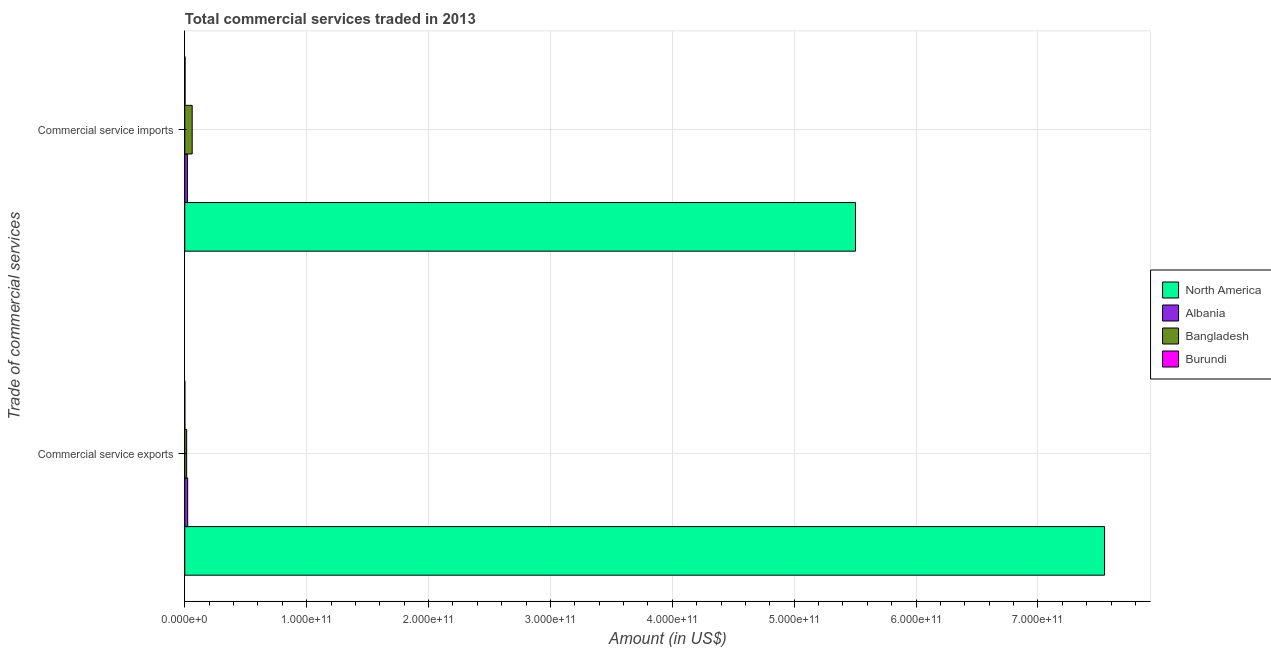How many bars are there on the 1st tick from the top?
Your answer should be very brief. 4. What is the label of the 1st group of bars from the top?
Make the answer very short. Commercial service imports. What is the amount of commercial service imports in Bangladesh?
Provide a succinct answer. 6.08e+09. Across all countries, what is the maximum amount of commercial service imports?
Provide a succinct answer. 5.50e+11. Across all countries, what is the minimum amount of commercial service imports?
Keep it short and to the point. 2.21e+08. In which country was the amount of commercial service exports maximum?
Your answer should be very brief. North America. In which country was the amount of commercial service exports minimum?
Provide a short and direct response. Burundi. What is the total amount of commercial service exports in the graph?
Your answer should be compact. 7.59e+11. What is the difference between the amount of commercial service exports in Bangladesh and that in Burundi?
Your answer should be compact. 1.50e+09. What is the difference between the amount of commercial service exports in Burundi and the amount of commercial service imports in Albania?
Your answer should be very brief. -2.13e+09. What is the average amount of commercial service exports per country?
Ensure brevity in your answer.  1.90e+11. What is the difference between the amount of commercial service imports and amount of commercial service exports in Burundi?
Give a very brief answer. 1.89e+08. In how many countries, is the amount of commercial service imports greater than 660000000000 US$?
Your response must be concise. 0. What is the ratio of the amount of commercial service imports in Bangladesh to that in North America?
Keep it short and to the point. 0.01. Is the amount of commercial service imports in Albania less than that in North America?
Your answer should be very brief. Yes. In how many countries, is the amount of commercial service imports greater than the average amount of commercial service imports taken over all countries?
Offer a very short reply. 1. What does the 2nd bar from the top in Commercial service exports represents?
Offer a very short reply. Bangladesh. What does the 1st bar from the bottom in Commercial service imports represents?
Provide a succinct answer. North America. How many bars are there?
Give a very brief answer. 8. What is the difference between two consecutive major ticks on the X-axis?
Your response must be concise. 1.00e+11. How are the legend labels stacked?
Offer a very short reply. Vertical. What is the title of the graph?
Your response must be concise. Total commercial services traded in 2013. What is the label or title of the Y-axis?
Offer a very short reply. Trade of commercial services. What is the Amount (in US$) of North America in Commercial service exports?
Keep it short and to the point. 7.55e+11. What is the Amount (in US$) of Albania in Commercial service exports?
Your answer should be compact. 2.39e+09. What is the Amount (in US$) of Bangladesh in Commercial service exports?
Your response must be concise. 1.53e+09. What is the Amount (in US$) in Burundi in Commercial service exports?
Keep it short and to the point. 3.23e+07. What is the Amount (in US$) in North America in Commercial service imports?
Keep it short and to the point. 5.50e+11. What is the Amount (in US$) of Albania in Commercial service imports?
Make the answer very short. 2.17e+09. What is the Amount (in US$) in Bangladesh in Commercial service imports?
Ensure brevity in your answer.  6.08e+09. What is the Amount (in US$) of Burundi in Commercial service imports?
Your answer should be compact. 2.21e+08. Across all Trade of commercial services, what is the maximum Amount (in US$) of North America?
Provide a short and direct response. 7.55e+11. Across all Trade of commercial services, what is the maximum Amount (in US$) of Albania?
Ensure brevity in your answer.  2.39e+09. Across all Trade of commercial services, what is the maximum Amount (in US$) of Bangladesh?
Offer a terse response. 6.08e+09. Across all Trade of commercial services, what is the maximum Amount (in US$) of Burundi?
Ensure brevity in your answer.  2.21e+08. Across all Trade of commercial services, what is the minimum Amount (in US$) in North America?
Keep it short and to the point. 5.50e+11. Across all Trade of commercial services, what is the minimum Amount (in US$) of Albania?
Provide a succinct answer. 2.17e+09. Across all Trade of commercial services, what is the minimum Amount (in US$) in Bangladesh?
Your response must be concise. 1.53e+09. Across all Trade of commercial services, what is the minimum Amount (in US$) of Burundi?
Your response must be concise. 3.23e+07. What is the total Amount (in US$) of North America in the graph?
Make the answer very short. 1.31e+12. What is the total Amount (in US$) of Albania in the graph?
Provide a succinct answer. 4.56e+09. What is the total Amount (in US$) in Bangladesh in the graph?
Provide a short and direct response. 7.61e+09. What is the total Amount (in US$) of Burundi in the graph?
Give a very brief answer. 2.53e+08. What is the difference between the Amount (in US$) of North America in Commercial service exports and that in Commercial service imports?
Keep it short and to the point. 2.04e+11. What is the difference between the Amount (in US$) in Albania in Commercial service exports and that in Commercial service imports?
Give a very brief answer. 2.27e+08. What is the difference between the Amount (in US$) in Bangladesh in Commercial service exports and that in Commercial service imports?
Give a very brief answer. -4.54e+09. What is the difference between the Amount (in US$) of Burundi in Commercial service exports and that in Commercial service imports?
Provide a succinct answer. -1.89e+08. What is the difference between the Amount (in US$) in North America in Commercial service exports and the Amount (in US$) in Albania in Commercial service imports?
Make the answer very short. 7.53e+11. What is the difference between the Amount (in US$) in North America in Commercial service exports and the Amount (in US$) in Bangladesh in Commercial service imports?
Keep it short and to the point. 7.49e+11. What is the difference between the Amount (in US$) of North America in Commercial service exports and the Amount (in US$) of Burundi in Commercial service imports?
Your answer should be compact. 7.54e+11. What is the difference between the Amount (in US$) of Albania in Commercial service exports and the Amount (in US$) of Bangladesh in Commercial service imports?
Give a very brief answer. -3.69e+09. What is the difference between the Amount (in US$) of Albania in Commercial service exports and the Amount (in US$) of Burundi in Commercial service imports?
Give a very brief answer. 2.17e+09. What is the difference between the Amount (in US$) in Bangladesh in Commercial service exports and the Amount (in US$) in Burundi in Commercial service imports?
Offer a terse response. 1.31e+09. What is the average Amount (in US$) in North America per Trade of commercial services?
Provide a short and direct response. 6.53e+11. What is the average Amount (in US$) in Albania per Trade of commercial services?
Offer a very short reply. 2.28e+09. What is the average Amount (in US$) of Bangladesh per Trade of commercial services?
Offer a very short reply. 3.81e+09. What is the average Amount (in US$) in Burundi per Trade of commercial services?
Provide a short and direct response. 1.27e+08. What is the difference between the Amount (in US$) of North America and Amount (in US$) of Albania in Commercial service exports?
Your response must be concise. 7.52e+11. What is the difference between the Amount (in US$) in North America and Amount (in US$) in Bangladesh in Commercial service exports?
Ensure brevity in your answer.  7.53e+11. What is the difference between the Amount (in US$) in North America and Amount (in US$) in Burundi in Commercial service exports?
Provide a short and direct response. 7.55e+11. What is the difference between the Amount (in US$) in Albania and Amount (in US$) in Bangladesh in Commercial service exports?
Give a very brief answer. 8.59e+08. What is the difference between the Amount (in US$) in Albania and Amount (in US$) in Burundi in Commercial service exports?
Make the answer very short. 2.36e+09. What is the difference between the Amount (in US$) of Bangladesh and Amount (in US$) of Burundi in Commercial service exports?
Provide a succinct answer. 1.50e+09. What is the difference between the Amount (in US$) of North America and Amount (in US$) of Albania in Commercial service imports?
Offer a very short reply. 5.48e+11. What is the difference between the Amount (in US$) in North America and Amount (in US$) in Bangladesh in Commercial service imports?
Your answer should be compact. 5.44e+11. What is the difference between the Amount (in US$) of North America and Amount (in US$) of Burundi in Commercial service imports?
Give a very brief answer. 5.50e+11. What is the difference between the Amount (in US$) in Albania and Amount (in US$) in Bangladesh in Commercial service imports?
Keep it short and to the point. -3.91e+09. What is the difference between the Amount (in US$) of Albania and Amount (in US$) of Burundi in Commercial service imports?
Make the answer very short. 1.94e+09. What is the difference between the Amount (in US$) in Bangladesh and Amount (in US$) in Burundi in Commercial service imports?
Keep it short and to the point. 5.86e+09. What is the ratio of the Amount (in US$) of North America in Commercial service exports to that in Commercial service imports?
Offer a very short reply. 1.37. What is the ratio of the Amount (in US$) of Albania in Commercial service exports to that in Commercial service imports?
Provide a succinct answer. 1.1. What is the ratio of the Amount (in US$) in Bangladesh in Commercial service exports to that in Commercial service imports?
Make the answer very short. 0.25. What is the ratio of the Amount (in US$) of Burundi in Commercial service exports to that in Commercial service imports?
Offer a very short reply. 0.15. What is the difference between the highest and the second highest Amount (in US$) in North America?
Your answer should be compact. 2.04e+11. What is the difference between the highest and the second highest Amount (in US$) of Albania?
Ensure brevity in your answer.  2.27e+08. What is the difference between the highest and the second highest Amount (in US$) of Bangladesh?
Offer a very short reply. 4.54e+09. What is the difference between the highest and the second highest Amount (in US$) in Burundi?
Your response must be concise. 1.89e+08. What is the difference between the highest and the lowest Amount (in US$) in North America?
Your answer should be compact. 2.04e+11. What is the difference between the highest and the lowest Amount (in US$) of Albania?
Provide a short and direct response. 2.27e+08. What is the difference between the highest and the lowest Amount (in US$) of Bangladesh?
Offer a very short reply. 4.54e+09. What is the difference between the highest and the lowest Amount (in US$) of Burundi?
Your response must be concise. 1.89e+08. 